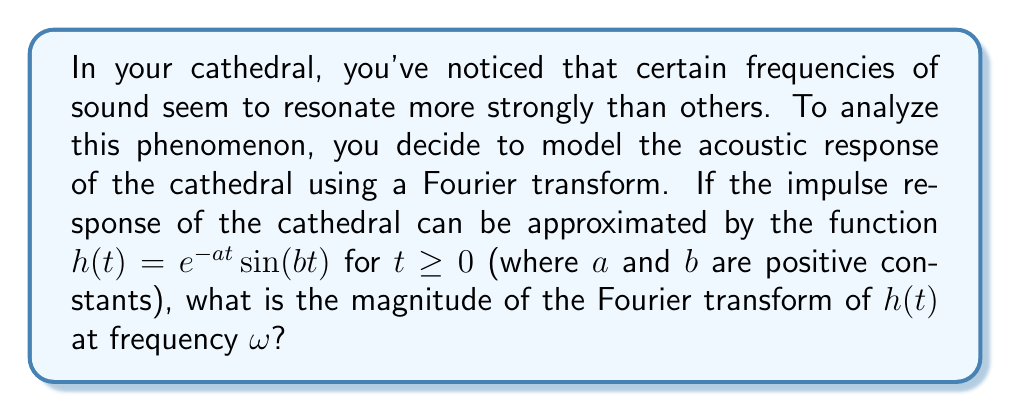Show me your answer to this math problem. Let's approach this step-by-step:

1) The Fourier transform of $h(t)$ is given by:

   $$H(\omega) = \int_{0}^{\infty} h(t)e^{-i\omega t} dt$$

2) Substituting our function $h(t) = e^{-at}\sin(bt)$, we get:

   $$H(\omega) = \int_{0}^{\infty} e^{-at}\sin(bt)e^{-i\omega t} dt$$

3) This integral can be solved using complex analysis, but for our purposes, we can state the result:

   $$H(\omega) = \frac{b}{(a+i\omega)^2 + b^2}$$

4) To find the magnitude of $H(\omega)$, we need to calculate $|H(\omega)|$:

   $$|H(\omega)| = \left|\frac{b}{(a+i\omega)^2 + b^2}\right|$$

5) Using the property $|z_1/z_2| = |z_1|/|z_2|$ for complex numbers, we get:

   $$|H(\omega)| = \frac{b}{\sqrt{((a+i\omega)^2 + b^2)((a-i\omega)^2 + b^2)}}$$

6) Simplifying the denominator:

   $$|H(\omega)| = \frac{b}{\sqrt{(a^2-\omega^2+b^2)^2 + (2a\omega)^2}}$$

This final expression gives the magnitude of the Fourier transform of the cathedral's impulse response at any frequency $\omega$.
Answer: $$|H(\omega)| = \frac{b}{\sqrt{(a^2-\omega^2+b^2)^2 + (2a\omega)^2}}$$ 